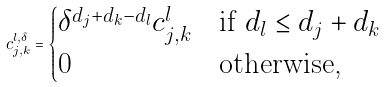Convert formula to latex. <formula><loc_0><loc_0><loc_500><loc_500>c _ { j , k } ^ { l , \delta } = \begin{cases} \delta ^ { d _ { j } + d _ { k } - d _ { l } } c _ { j , k } ^ { l } & \text {if } d _ { l } \leq d _ { j } + d _ { k } \\ 0 & \text {otherwise,} \end{cases}</formula> 